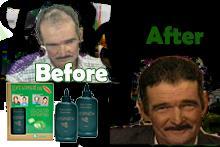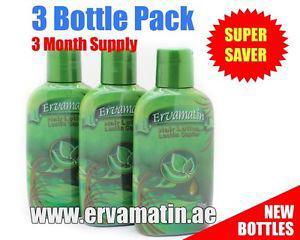The first image is the image on the left, the second image is the image on the right. Evaluate the accuracy of this statement regarding the images: "All of the bottles in the images are green.". Is it true? Answer yes or no. Yes. The first image is the image on the left, the second image is the image on the right. Analyze the images presented: Is the assertion "A female has her hand touching her face, and an upright bottle overlaps the image." valid? Answer yes or no. No. 